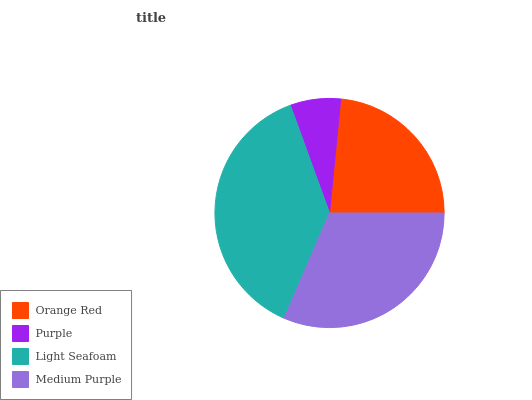Is Purple the minimum?
Answer yes or no. Yes. Is Light Seafoam the maximum?
Answer yes or no. Yes. Is Light Seafoam the minimum?
Answer yes or no. No. Is Purple the maximum?
Answer yes or no. No. Is Light Seafoam greater than Purple?
Answer yes or no. Yes. Is Purple less than Light Seafoam?
Answer yes or no. Yes. Is Purple greater than Light Seafoam?
Answer yes or no. No. Is Light Seafoam less than Purple?
Answer yes or no. No. Is Medium Purple the high median?
Answer yes or no. Yes. Is Orange Red the low median?
Answer yes or no. Yes. Is Orange Red the high median?
Answer yes or no. No. Is Light Seafoam the low median?
Answer yes or no. No. 